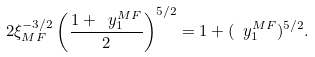Convert formula to latex. <formula><loc_0><loc_0><loc_500><loc_500>2 \xi _ { M F } ^ { - 3 / 2 } \left ( \frac { 1 + \ y ^ { M F } _ { 1 } } { 2 } \right ) ^ { 5 / 2 } = 1 + ( \ y ^ { M F } _ { 1 } ) ^ { 5 / 2 } .</formula> 